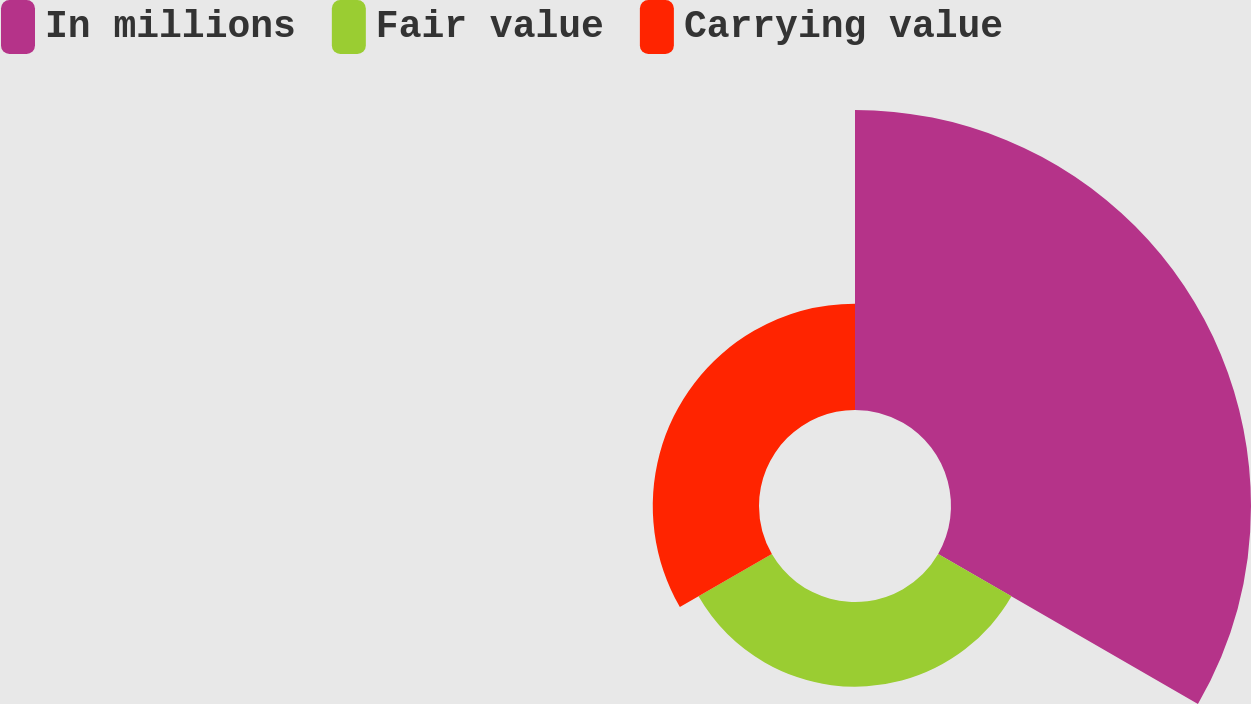Convert chart. <chart><loc_0><loc_0><loc_500><loc_500><pie_chart><fcel>In millions<fcel>Fair value<fcel>Carrying value<nl><fcel>61.11%<fcel>17.25%<fcel>21.64%<nl></chart> 